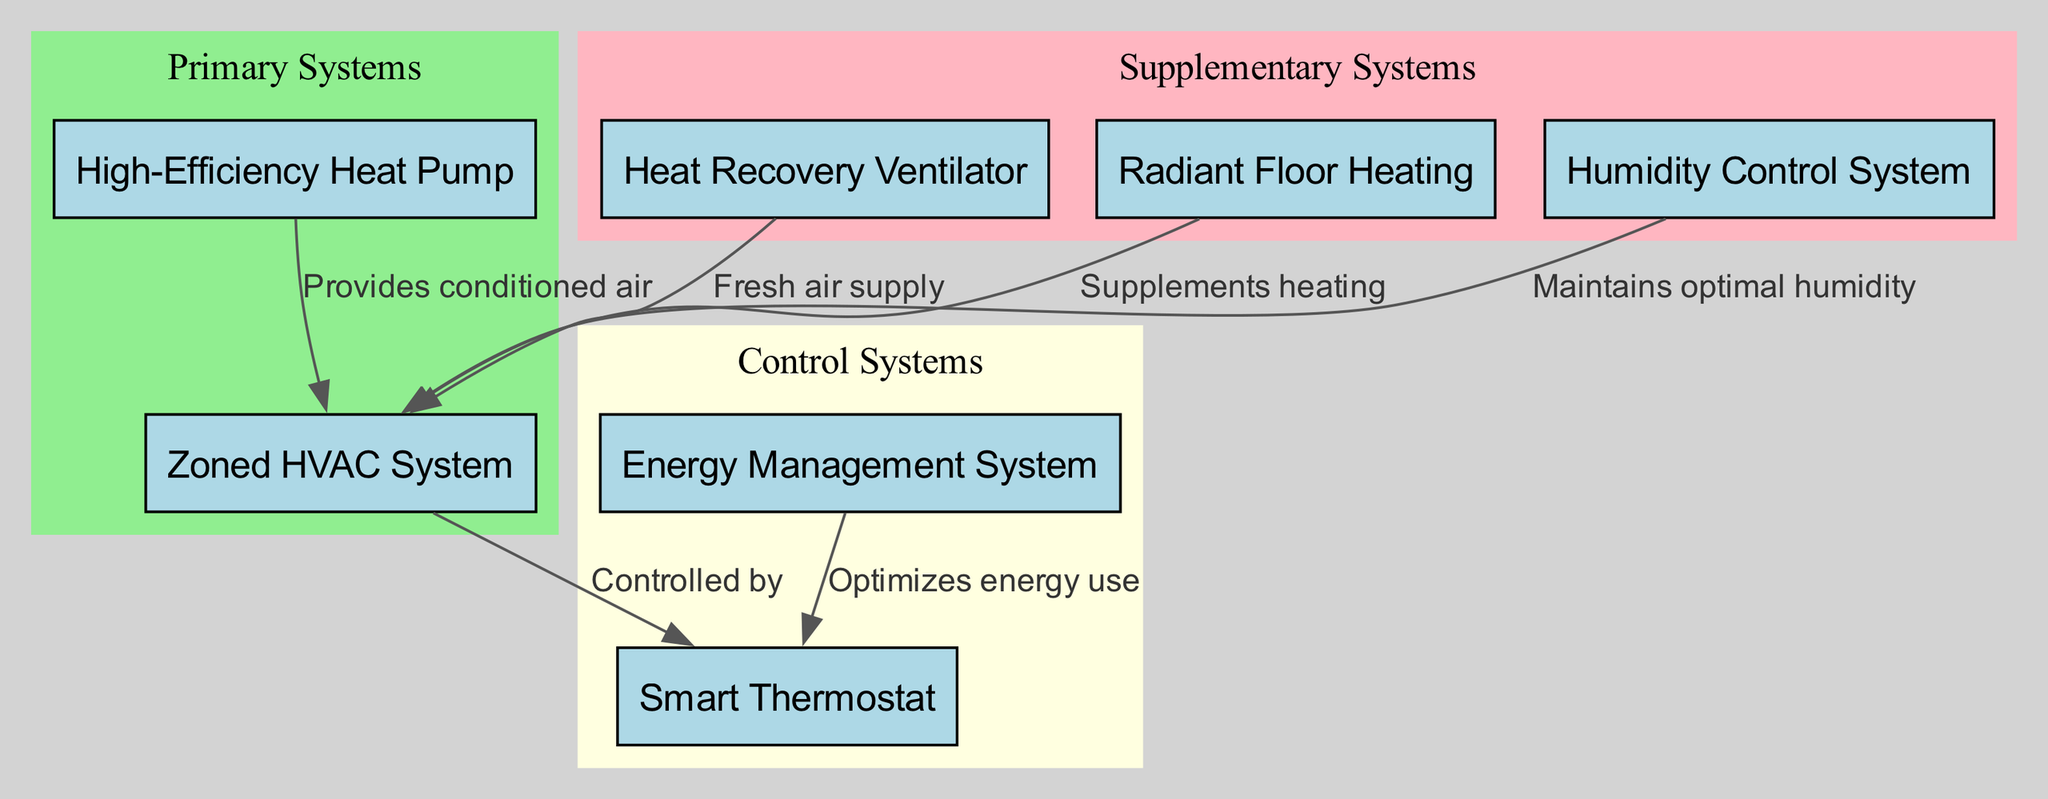What is the total number of nodes in the diagram? The diagram includes a total of 7 nodes that represent different components of the energy-efficient HVAC system, as listed in the data.
Answer: 7 What component maintains optimal humidity? The diagram directly connects the Humidity Control System to the Zoned HVAC System, indicating its role in maintaining optimal humidity levels.
Answer: Humidity Control System Which system is controlled by the Smart Thermostat? The Smart Thermostat has a directed edge pointing to the Zoned HVAC System, indicating it is the system that is controlled by the thermostat.
Answer: Zoned HVAC System What flows from the High-Efficiency Heat Pump to the Zoned HVAC System? According to the diagram, the edge indicates that the High-Efficiency Heat Pump provides conditioned air to the Zoned HVAC System.
Answer: Conditioned air What is the purpose of the Heat Recovery Ventilator in this diagram? The Heat Recovery Ventilator is shown to supply fresh air to the Zoned HVAC System, indicating its purpose to enhance air quality by introducing fresh air.
Answer: Fresh air supply How many supplementary systems are identified in the diagram? Reviewing the diagram, three supplementary systems are indicated: Heat Recovery Ventilator, Radiant Floor Heating, and Humidity Control System.
Answer: 3 Which systems work under the control of the Smart Thermostat? The Smart Thermostat controls the Zoned HVAC System, which means that any interactions or functions it manages happen through this specific system.
Answer: Zoned HVAC System What system optimizes energy use and is connected to the Smart Thermostat? The Energy Management System is positioned to optimize energy use, and it connects to the Smart Thermostat as indicated in the diagram's edges.
Answer: Energy Management System Which two systems support the Zoned HVAC System for heating? The Radiant Floor Heating and the High-Efficiency Heat Pump supplement heating for the Zoned HVAC System, as indicated by directed edges showing their supportive relationship.
Answer: Radiant Floor Heating and High-Efficiency Heat Pump 